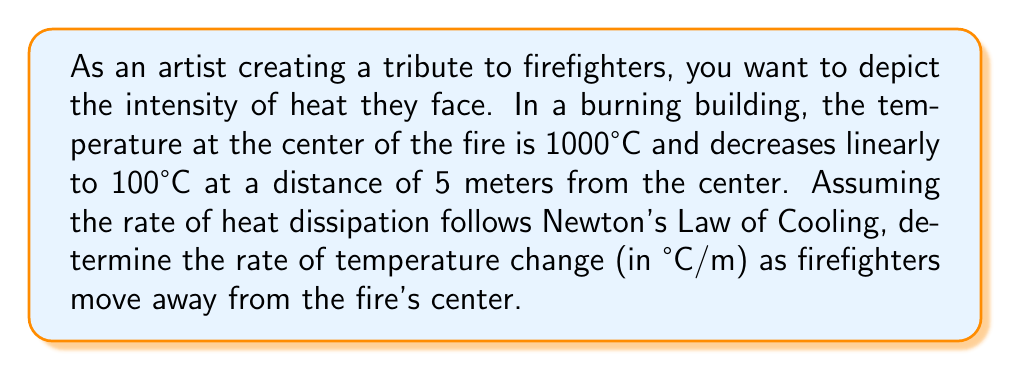Could you help me with this problem? To solve this problem, we'll use the concept of linear temperature distribution and the rate of change. Let's break it down step-by-step:

1) We're given that the temperature decreases linearly from the center of the fire to a point 5 meters away. We can represent this as a linear function:

   $T(x) = mx + b$

   where $T$ is temperature, $x$ is distance from the center, $m$ is the slope (rate of change), and $b$ is the y-intercept (temperature at the center).

2) We know two points on this line:
   - At $x = 0$ (center), $T = 1000°C$
   - At $x = 5$ meters, $T = 100°C$

3) We can use these points to find the slope $m$, which represents the rate of temperature change:

   $m = \frac{T_2 - T_1}{x_2 - x_1} = \frac{100°C - 1000°C}{5m - 0m} = \frac{-900°C}{5m} = -180°C/m$

4) The negative sign indicates that the temperature is decreasing as we move away from the center.

5) This slope, $-180°C/m$, represents the rate of heat dissipation or the rate of temperature change as firefighters move away from the fire's center.
Answer: $-180°C/m$ 